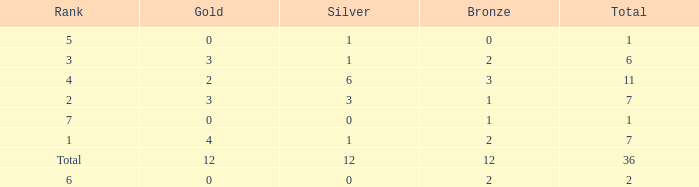Give me the full table as a dictionary. {'header': ['Rank', 'Gold', 'Silver', 'Bronze', 'Total'], 'rows': [['5', '0', '1', '0', '1'], ['3', '3', '1', '2', '6'], ['4', '2', '6', '3', '11'], ['2', '3', '3', '1', '7'], ['7', '0', '0', '1', '1'], ['1', '4', '1', '2', '7'], ['Total', '12', '12', '12', '36'], ['6', '0', '0', '2', '2']]} What is the largest total for a team with 1 bronze, 0 gold medals and ranking of 7? None. 